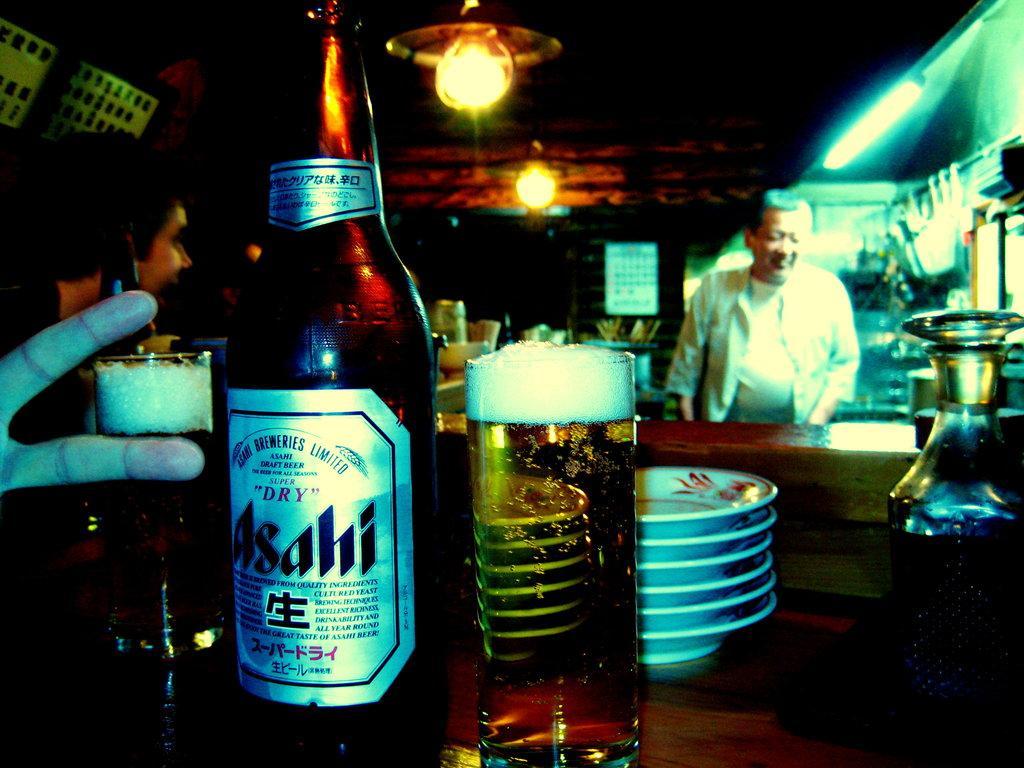Describe this image in one or two sentences. In this image, There is a table on that table there are some glasses and there is a wine bottle which is in black color, In the background there is a person standing and there are some lights which are in yellow color. 